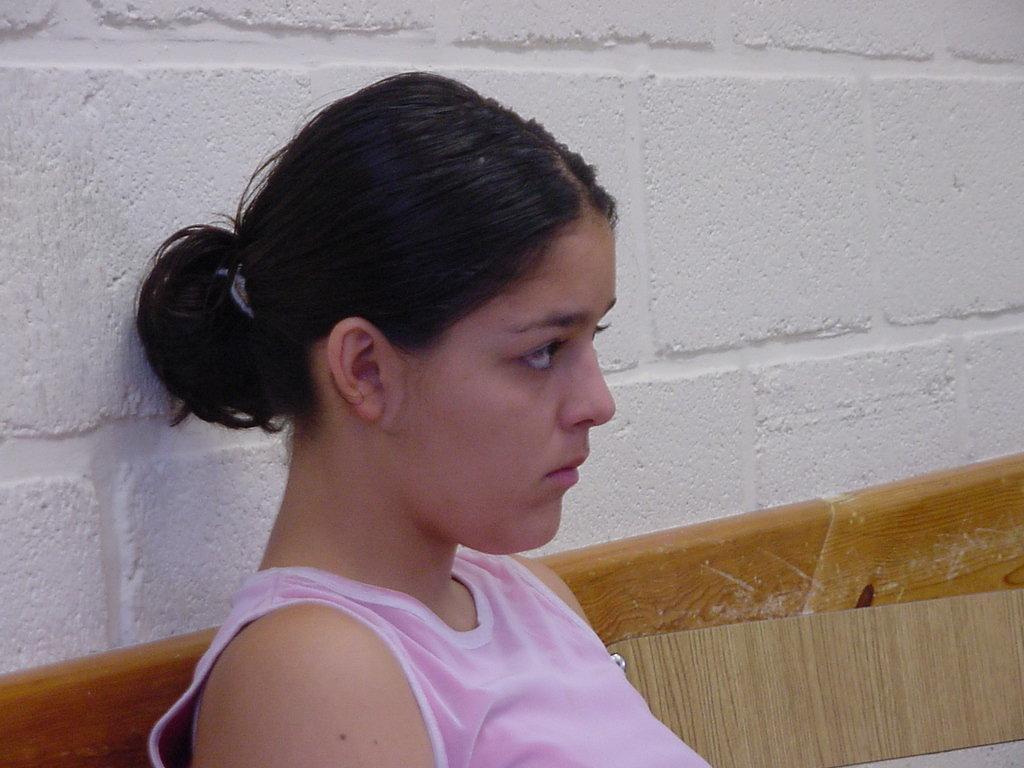Describe this image in one or two sentences. In this image we can see a person sitting on the bench. In the background there is a wall. 